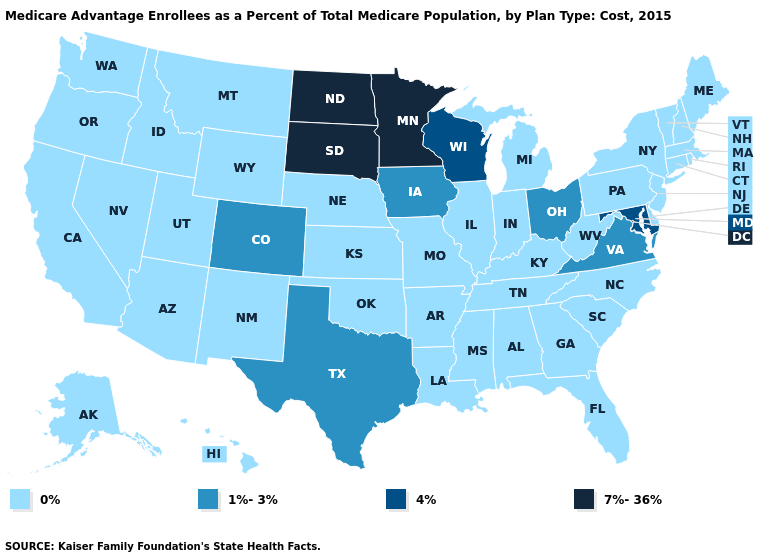What is the highest value in the USA?
Quick response, please. 7%-36%. What is the value of New Jersey?
Quick response, please. 0%. Name the states that have a value in the range 1%-3%?
Give a very brief answer. Colorado, Iowa, Ohio, Texas, Virginia. What is the lowest value in the USA?
Give a very brief answer. 0%. What is the value of New Hampshire?
Short answer required. 0%. Name the states that have a value in the range 7%-36%?
Be succinct. Minnesota, North Dakota, South Dakota. What is the value of New York?
Short answer required. 0%. What is the value of Washington?
Concise answer only. 0%. Which states have the highest value in the USA?
Give a very brief answer. Minnesota, North Dakota, South Dakota. What is the value of Arizona?
Quick response, please. 0%. Name the states that have a value in the range 7%-36%?
Give a very brief answer. Minnesota, North Dakota, South Dakota. Does South Carolina have a lower value than New Jersey?
Write a very short answer. No. What is the value of Oregon?
Answer briefly. 0%. What is the value of Alaska?
Be succinct. 0%. 